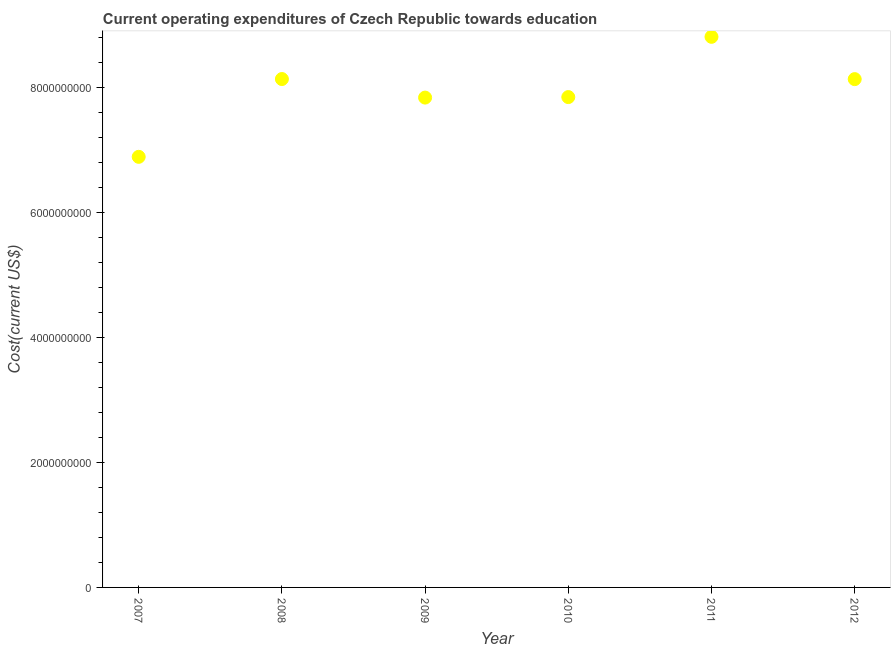What is the education expenditure in 2010?
Keep it short and to the point. 7.85e+09. Across all years, what is the maximum education expenditure?
Provide a short and direct response. 8.81e+09. Across all years, what is the minimum education expenditure?
Ensure brevity in your answer.  6.89e+09. In which year was the education expenditure maximum?
Ensure brevity in your answer.  2011. In which year was the education expenditure minimum?
Give a very brief answer. 2007. What is the sum of the education expenditure?
Provide a succinct answer. 4.77e+1. What is the difference between the education expenditure in 2009 and 2010?
Your answer should be very brief. -8.16e+06. What is the average education expenditure per year?
Make the answer very short. 7.95e+09. What is the median education expenditure?
Provide a short and direct response. 7.99e+09. Do a majority of the years between 2010 and 2007 (inclusive) have education expenditure greater than 3200000000 US$?
Your response must be concise. Yes. What is the ratio of the education expenditure in 2008 to that in 2012?
Keep it short and to the point. 1. Is the education expenditure in 2008 less than that in 2012?
Make the answer very short. No. What is the difference between the highest and the second highest education expenditure?
Offer a terse response. 6.76e+08. What is the difference between the highest and the lowest education expenditure?
Provide a succinct answer. 1.92e+09. In how many years, is the education expenditure greater than the average education expenditure taken over all years?
Make the answer very short. 3. Does the graph contain any zero values?
Your answer should be compact. No. What is the title of the graph?
Offer a terse response. Current operating expenditures of Czech Republic towards education. What is the label or title of the Y-axis?
Make the answer very short. Cost(current US$). What is the Cost(current US$) in 2007?
Make the answer very short. 6.89e+09. What is the Cost(current US$) in 2008?
Give a very brief answer. 8.14e+09. What is the Cost(current US$) in 2009?
Your answer should be very brief. 7.84e+09. What is the Cost(current US$) in 2010?
Make the answer very short. 7.85e+09. What is the Cost(current US$) in 2011?
Your answer should be compact. 8.81e+09. What is the Cost(current US$) in 2012?
Give a very brief answer. 8.14e+09. What is the difference between the Cost(current US$) in 2007 and 2008?
Make the answer very short. -1.25e+09. What is the difference between the Cost(current US$) in 2007 and 2009?
Provide a succinct answer. -9.48e+08. What is the difference between the Cost(current US$) in 2007 and 2010?
Your answer should be very brief. -9.56e+08. What is the difference between the Cost(current US$) in 2007 and 2011?
Make the answer very short. -1.92e+09. What is the difference between the Cost(current US$) in 2007 and 2012?
Your answer should be compact. -1.24e+09. What is the difference between the Cost(current US$) in 2008 and 2009?
Your answer should be very brief. 2.97e+08. What is the difference between the Cost(current US$) in 2008 and 2010?
Give a very brief answer. 2.89e+08. What is the difference between the Cost(current US$) in 2008 and 2011?
Your answer should be very brief. -6.76e+08. What is the difference between the Cost(current US$) in 2008 and 2012?
Your answer should be compact. 1.27e+06. What is the difference between the Cost(current US$) in 2009 and 2010?
Make the answer very short. -8.16e+06. What is the difference between the Cost(current US$) in 2009 and 2011?
Your response must be concise. -9.73e+08. What is the difference between the Cost(current US$) in 2009 and 2012?
Provide a succinct answer. -2.96e+08. What is the difference between the Cost(current US$) in 2010 and 2011?
Your answer should be very brief. -9.65e+08. What is the difference between the Cost(current US$) in 2010 and 2012?
Ensure brevity in your answer.  -2.87e+08. What is the difference between the Cost(current US$) in 2011 and 2012?
Your response must be concise. 6.77e+08. What is the ratio of the Cost(current US$) in 2007 to that in 2008?
Make the answer very short. 0.85. What is the ratio of the Cost(current US$) in 2007 to that in 2009?
Offer a very short reply. 0.88. What is the ratio of the Cost(current US$) in 2007 to that in 2010?
Ensure brevity in your answer.  0.88. What is the ratio of the Cost(current US$) in 2007 to that in 2011?
Your answer should be very brief. 0.78. What is the ratio of the Cost(current US$) in 2007 to that in 2012?
Make the answer very short. 0.85. What is the ratio of the Cost(current US$) in 2008 to that in 2009?
Offer a very short reply. 1.04. What is the ratio of the Cost(current US$) in 2008 to that in 2011?
Your answer should be compact. 0.92. What is the ratio of the Cost(current US$) in 2009 to that in 2011?
Your answer should be compact. 0.89. What is the ratio of the Cost(current US$) in 2010 to that in 2011?
Make the answer very short. 0.89. What is the ratio of the Cost(current US$) in 2011 to that in 2012?
Make the answer very short. 1.08. 